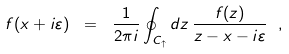Convert formula to latex. <formula><loc_0><loc_0><loc_500><loc_500>f ( x + i \varepsilon ) \ = \ \frac { 1 } { 2 \pi i } \oint _ { C _ { \uparrow } } d z \, \frac { f ( z ) } { z - x - i \varepsilon } \ ,</formula> 